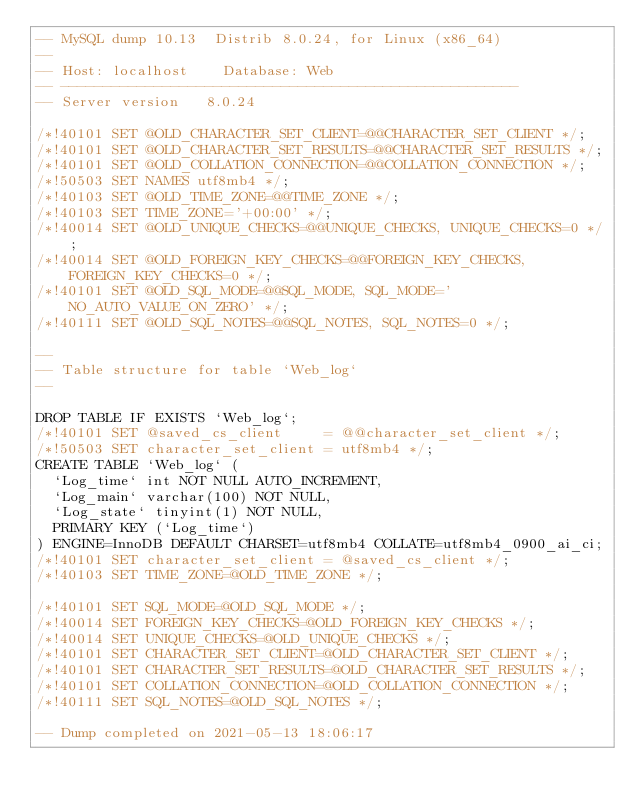Convert code to text. <code><loc_0><loc_0><loc_500><loc_500><_SQL_>-- MySQL dump 10.13  Distrib 8.0.24, for Linux (x86_64)
--
-- Host: localhost    Database: Web
-- ------------------------------------------------------
-- Server version	8.0.24

/*!40101 SET @OLD_CHARACTER_SET_CLIENT=@@CHARACTER_SET_CLIENT */;
/*!40101 SET @OLD_CHARACTER_SET_RESULTS=@@CHARACTER_SET_RESULTS */;
/*!40101 SET @OLD_COLLATION_CONNECTION=@@COLLATION_CONNECTION */;
/*!50503 SET NAMES utf8mb4 */;
/*!40103 SET @OLD_TIME_ZONE=@@TIME_ZONE */;
/*!40103 SET TIME_ZONE='+00:00' */;
/*!40014 SET @OLD_UNIQUE_CHECKS=@@UNIQUE_CHECKS, UNIQUE_CHECKS=0 */;
/*!40014 SET @OLD_FOREIGN_KEY_CHECKS=@@FOREIGN_KEY_CHECKS, FOREIGN_KEY_CHECKS=0 */;
/*!40101 SET @OLD_SQL_MODE=@@SQL_MODE, SQL_MODE='NO_AUTO_VALUE_ON_ZERO' */;
/*!40111 SET @OLD_SQL_NOTES=@@SQL_NOTES, SQL_NOTES=0 */;

--
-- Table structure for table `Web_log`
--

DROP TABLE IF EXISTS `Web_log`;
/*!40101 SET @saved_cs_client     = @@character_set_client */;
/*!50503 SET character_set_client = utf8mb4 */;
CREATE TABLE `Web_log` (
  `Log_time` int NOT NULL AUTO_INCREMENT,
  `Log_main` varchar(100) NOT NULL,
  `Log_state` tinyint(1) NOT NULL,
  PRIMARY KEY (`Log_time`)
) ENGINE=InnoDB DEFAULT CHARSET=utf8mb4 COLLATE=utf8mb4_0900_ai_ci;
/*!40101 SET character_set_client = @saved_cs_client */;
/*!40103 SET TIME_ZONE=@OLD_TIME_ZONE */;

/*!40101 SET SQL_MODE=@OLD_SQL_MODE */;
/*!40014 SET FOREIGN_KEY_CHECKS=@OLD_FOREIGN_KEY_CHECKS */;
/*!40014 SET UNIQUE_CHECKS=@OLD_UNIQUE_CHECKS */;
/*!40101 SET CHARACTER_SET_CLIENT=@OLD_CHARACTER_SET_CLIENT */;
/*!40101 SET CHARACTER_SET_RESULTS=@OLD_CHARACTER_SET_RESULTS */;
/*!40101 SET COLLATION_CONNECTION=@OLD_COLLATION_CONNECTION */;
/*!40111 SET SQL_NOTES=@OLD_SQL_NOTES */;

-- Dump completed on 2021-05-13 18:06:17
</code> 